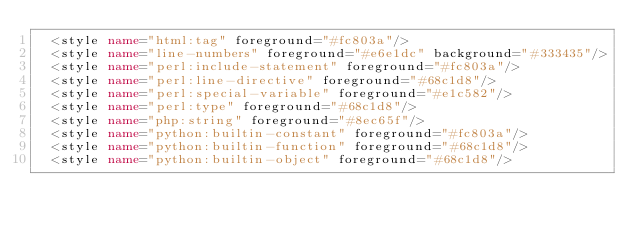Convert code to text. <code><loc_0><loc_0><loc_500><loc_500><_XML_>  <style name="html:tag" foreground="#fc803a"/>
  <style name="line-numbers" foreground="#e6e1dc" background="#333435"/>
  <style name="perl:include-statement" foreground="#fc803a"/>
  <style name="perl:line-directive" foreground="#68c1d8"/>
  <style name="perl:special-variable" foreground="#e1c582"/>
  <style name="perl:type" foreground="#68c1d8"/>
  <style name="php:string" foreground="#8ec65f"/>
  <style name="python:builtin-constant" foreground="#fc803a"/>
  <style name="python:builtin-function" foreground="#68c1d8"/>
  <style name="python:builtin-object" foreground="#68c1d8"/></code> 